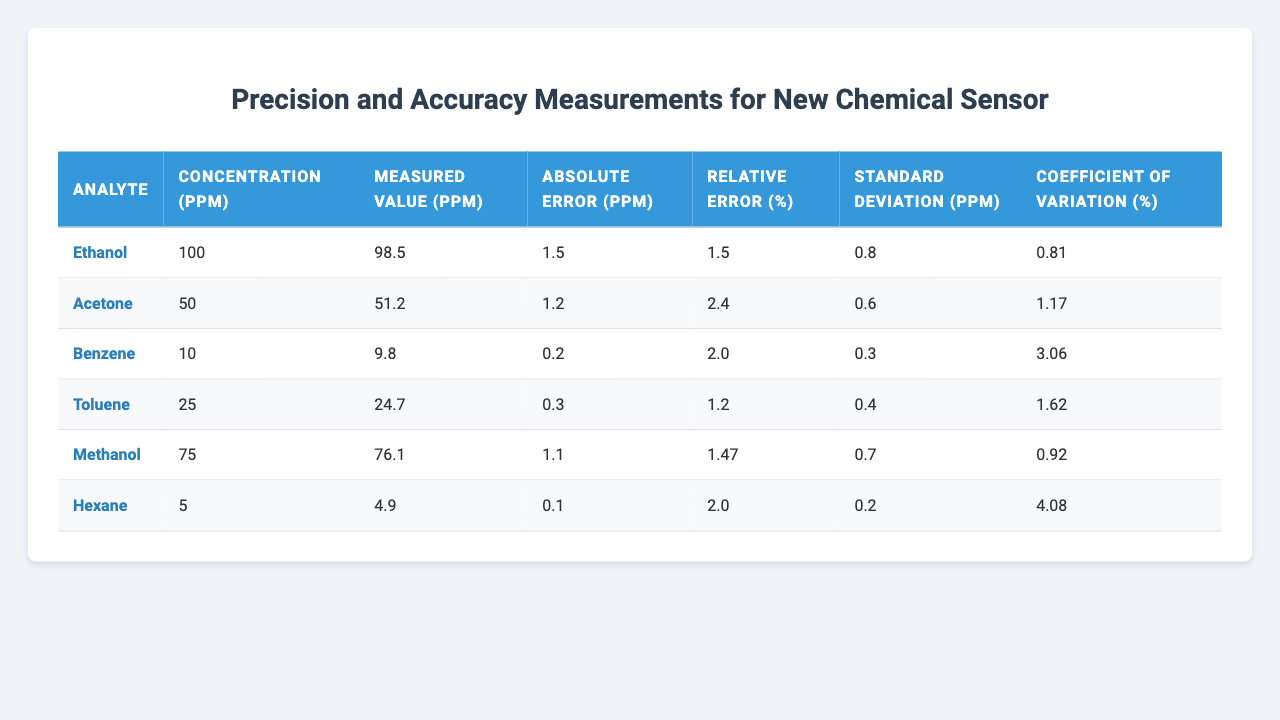What is the measured value for Ethanol? The table indicates that the measured value for Ethanol is listed under the "Measured Value (ppm)" column. Referring to the corresponding row for Ethanol, the value is 98.5 ppm.
Answer: 98.5 ppm What is the absolute error for Acetone? The absolute error for Acetone can be found in the "Absolute Error (ppm)" column. Looking at the Acetone row, it shows an absolute error of 1.2 ppm.
Answer: 1.2 ppm What is the relative error percentage for Benzene? The relative error for Benzene is provided in the "Relative Error (%)" column. The Benzene row displays a relative error percentage of 2.0%.
Answer: 2.0% Which analyte has the lowest coefficient of variation? To determine which analyte has the lowest coefficient of variation, compare the values in the "Coefficient of Variation (%)" column across all analytes. The lowest value is 0.81 for Ethanol.
Answer: Ethanol What is the average absolute error of all analytes? Calculate the average absolute error by summing the absolute errors: (1.5 + 1.2 + 0.2 + 0.3 + 1.1 + 0.1) = 4.4 ppm. There are 6 analytes, so dividing gives an average of 4.4 / 6 = 0.7333 ppm.
Answer: 0.73 ppm Does Methanol have a lower standard deviation than Toluene? To answer this, compare the "Standard Deviation (ppm)" values for both Methanol (0.7 ppm) and Toluene (0.4 ppm). Since 0.7 is greater than 0.4, Methanol does not have a lower standard deviation than Toluene.
Answer: No What is the concentration difference between Hexane and Benzene? The concentration for Hexane is 5 ppm and for Benzene is 10 ppm. The difference is calculated by subtracting Hexane's concentration from Benzene's: 10 - 5 = 5 ppm.
Answer: 5 ppm Which analyte shows the highest relative error? The relative errors for all analytes are compared in the "Relative Error (%)" column. The highest relative error is 3.06% for Hexane.
Answer: Hexane What is the relationship between the measured value of Methanol and its concentration? The measured value of Methanol is 76.1 ppm, while its concentration is 75 ppm. The measured value is greater than the concentration, indicating a slight overestimation.
Answer: Measured value is higher Is the standard deviation for Acetone higher than for Ethanol? Compare the values in the "Standard Deviation (ppm)" column for Acetone (0.6 ppm) and Ethanol (0.8 ppm). Since 0.6 is less than 0.8, Acetone does not have a higher standard deviation than Ethanol.
Answer: No 